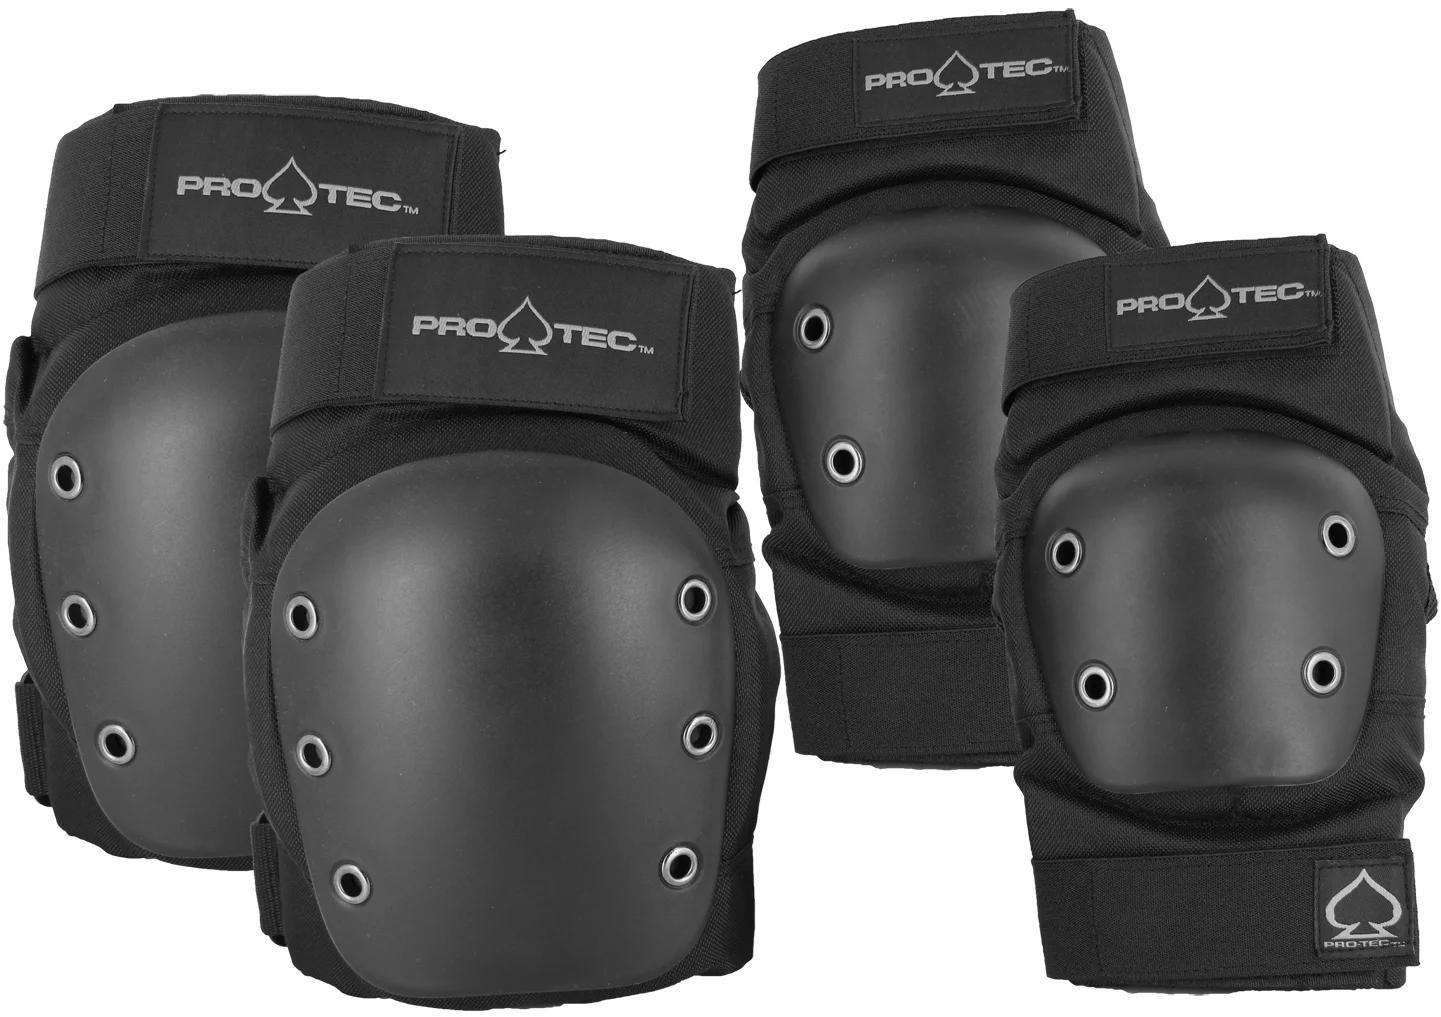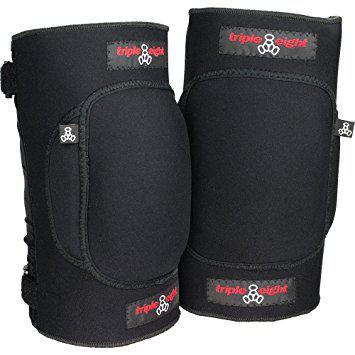The first image is the image on the left, the second image is the image on the right. Evaluate the accuracy of this statement regarding the images: "One image shows a pair of legs in shorts wearing a pair of black knee pads, and the other image features an unworn pair of black kneepads.". Is it true? Answer yes or no. No. The first image is the image on the left, the second image is the image on the right. Assess this claim about the two images: "The left and right image contains the same number of knee pads.". Correct or not? Answer yes or no. No. 